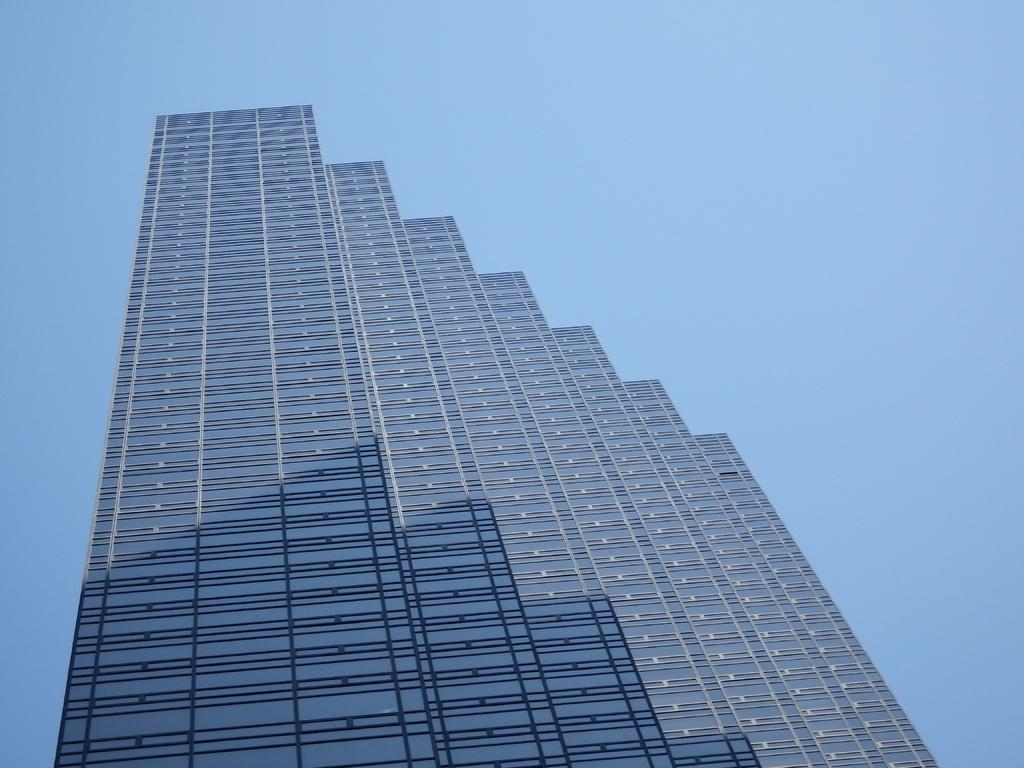What is located in the foreground of the image? There is a building in the foreground of the image. What can be seen in the background of the image? The sky is visible in the background of the image. What type of plastic material is visible in the image? There is no plastic material present in the image. How does the building in the image increase in size? The building in the image does not increase in size; it is a static structure. 